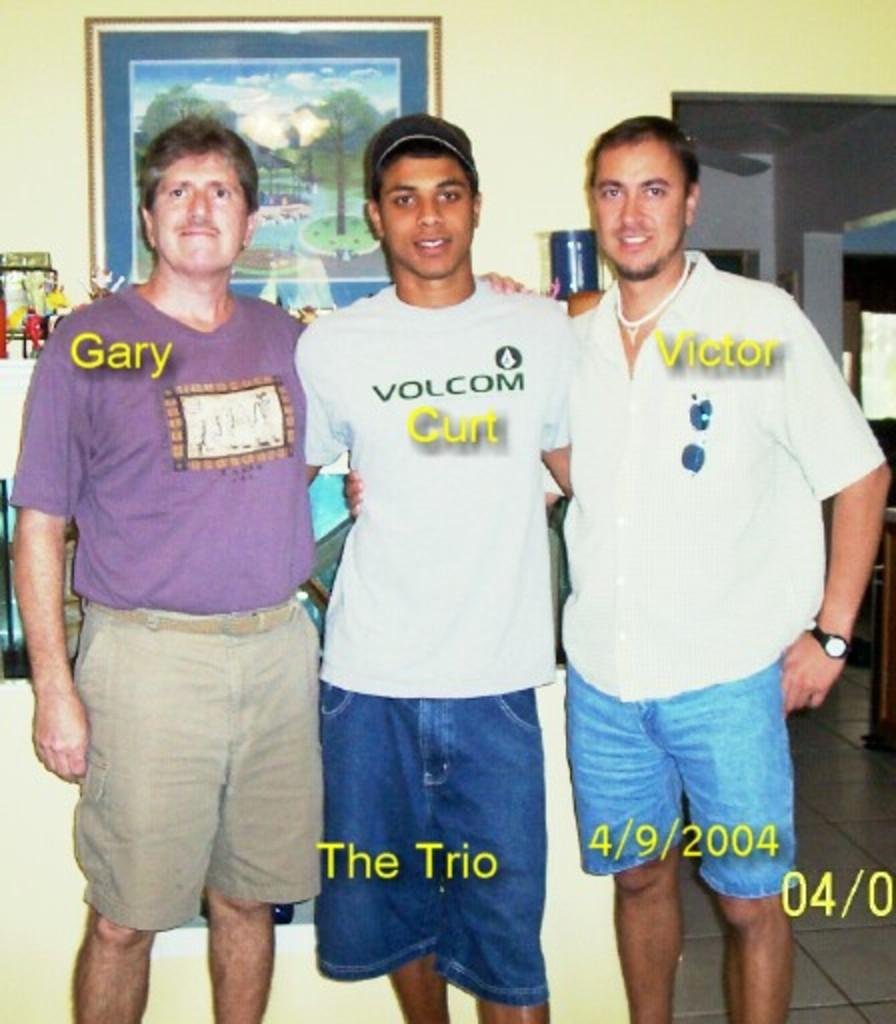How many people are in the image? There are three persons in the image. What else can be seen in the image besides the people? Text is visible in the image, and there is a wall with a photo frame on it. Can you describe the wall in the image? The wall has a photo frame on it. What type of celery can be seen growing in the photo frame? There is no celery present in the image, and the photo frame does not depict any plants or vegetables. 